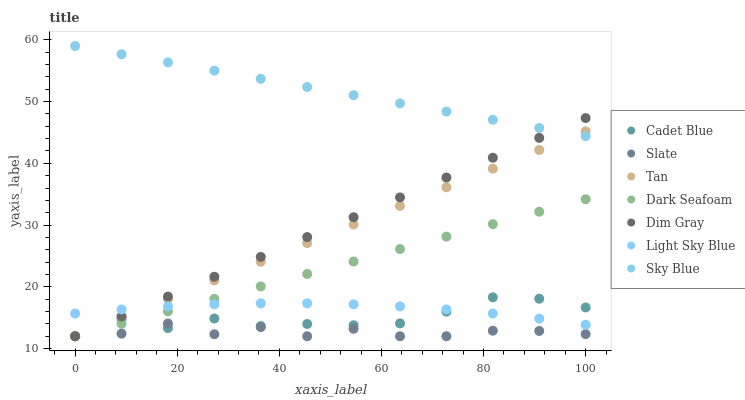Does Slate have the minimum area under the curve?
Answer yes or no. Yes. Does Sky Blue have the maximum area under the curve?
Answer yes or no. Yes. Does Dark Seafoam have the minimum area under the curve?
Answer yes or no. No. Does Dark Seafoam have the maximum area under the curve?
Answer yes or no. No. Is Dark Seafoam the smoothest?
Answer yes or no. Yes. Is Slate the roughest?
Answer yes or no. Yes. Is Slate the smoothest?
Answer yes or no. No. Is Dark Seafoam the roughest?
Answer yes or no. No. Does Dim Gray have the lowest value?
Answer yes or no. Yes. Does Light Sky Blue have the lowest value?
Answer yes or no. No. Does Sky Blue have the highest value?
Answer yes or no. Yes. Does Dark Seafoam have the highest value?
Answer yes or no. No. Is Dark Seafoam less than Sky Blue?
Answer yes or no. Yes. Is Sky Blue greater than Slate?
Answer yes or no. Yes. Does Tan intersect Dark Seafoam?
Answer yes or no. Yes. Is Tan less than Dark Seafoam?
Answer yes or no. No. Is Tan greater than Dark Seafoam?
Answer yes or no. No. Does Dark Seafoam intersect Sky Blue?
Answer yes or no. No. 